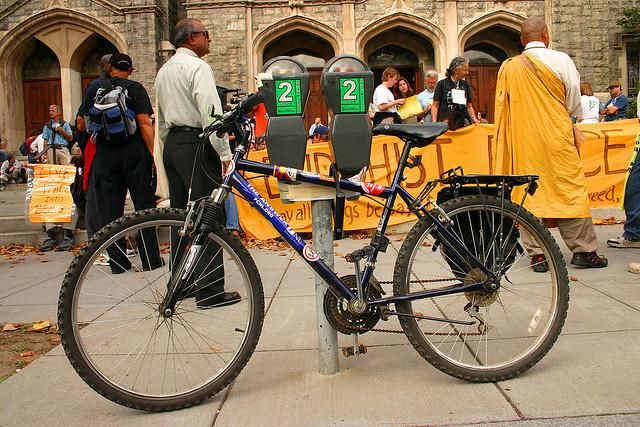How old is the bike?
Answer briefly. Can't tell. What number is on the sticker on the parking meter?
Be succinct. 2. What color is the bike?
Concise answer only. Blue. 